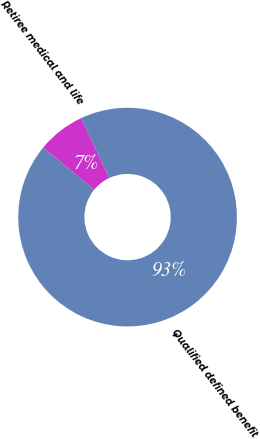Convert chart to OTSL. <chart><loc_0><loc_0><loc_500><loc_500><pie_chart><fcel>Qualified defined benefit<fcel>Retiree medical and life<nl><fcel>92.96%<fcel>7.04%<nl></chart> 